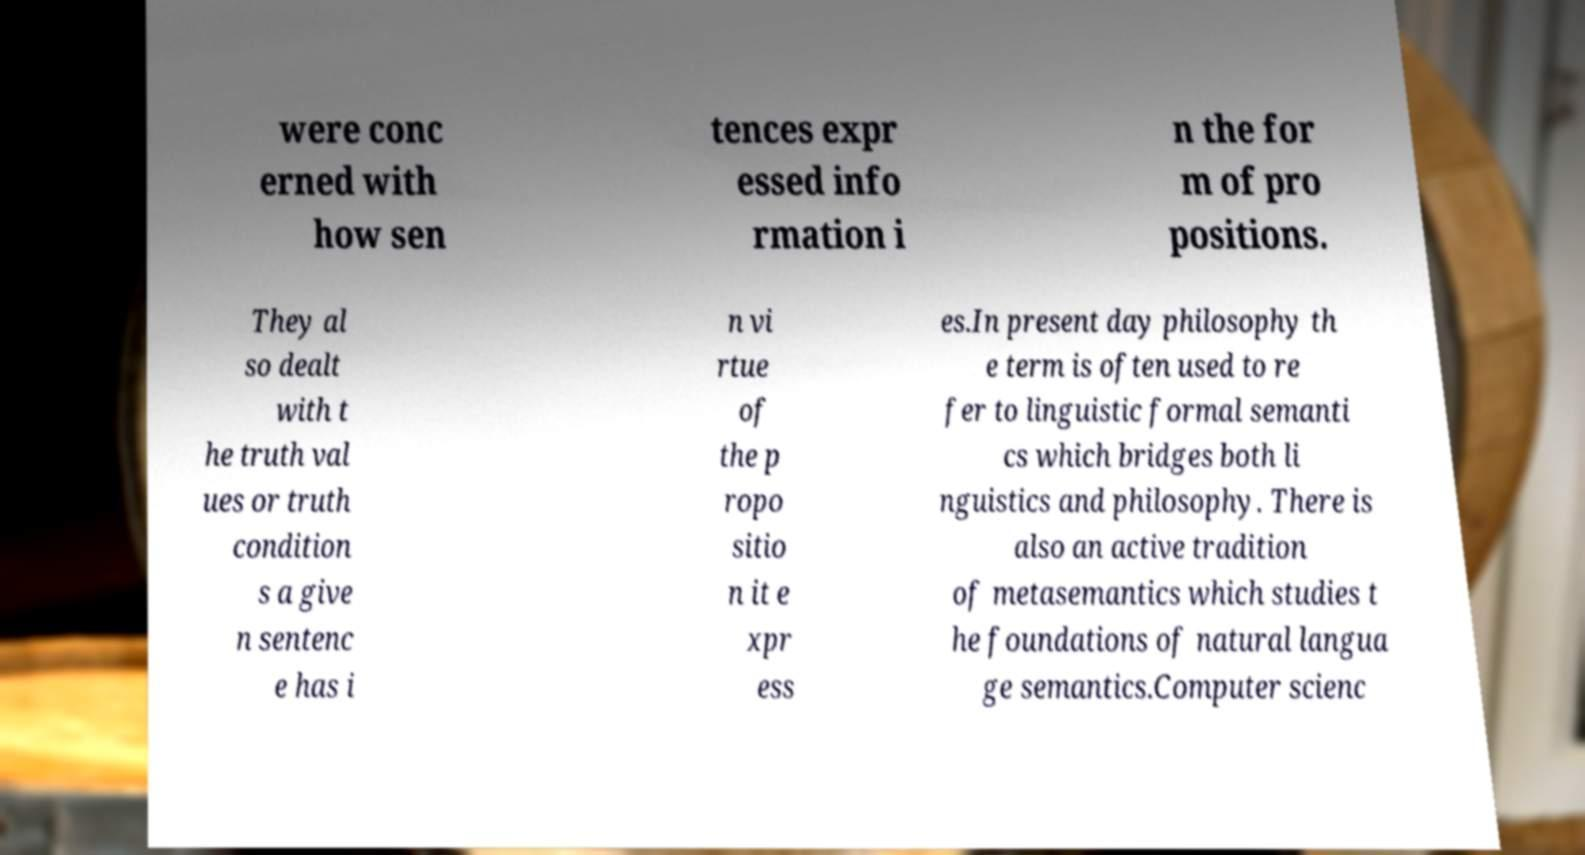Could you extract and type out the text from this image? were conc erned with how sen tences expr essed info rmation i n the for m of pro positions. They al so dealt with t he truth val ues or truth condition s a give n sentenc e has i n vi rtue of the p ropo sitio n it e xpr ess es.In present day philosophy th e term is often used to re fer to linguistic formal semanti cs which bridges both li nguistics and philosophy. There is also an active tradition of metasemantics which studies t he foundations of natural langua ge semantics.Computer scienc 